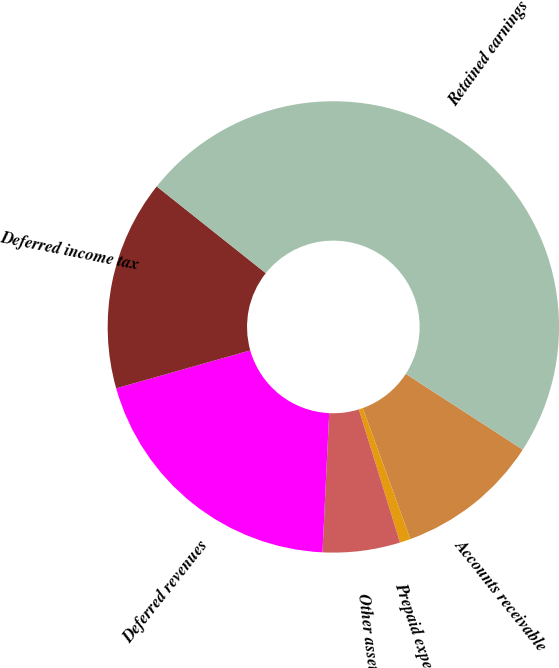Convert chart to OTSL. <chart><loc_0><loc_0><loc_500><loc_500><pie_chart><fcel>Accounts receivable<fcel>Prepaid expenses<fcel>Other assets<fcel>Deferred revenues<fcel>Deferred income tax<fcel>Retained earnings<nl><fcel>10.31%<fcel>0.77%<fcel>5.54%<fcel>19.85%<fcel>15.08%<fcel>48.46%<nl></chart> 